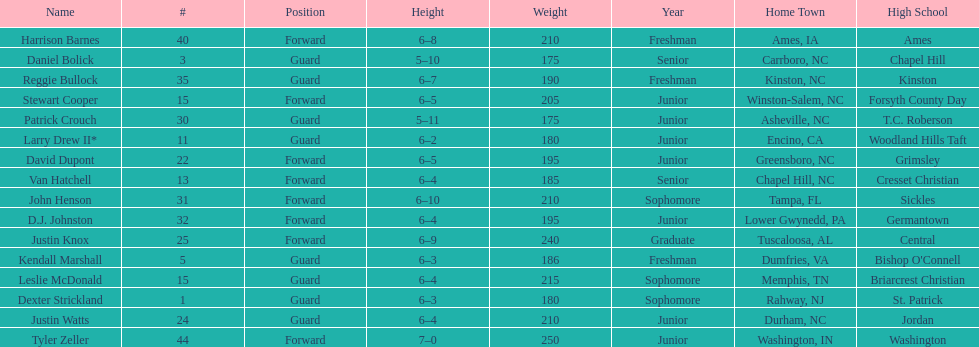Highest player on the squad Tyler Zeller. 